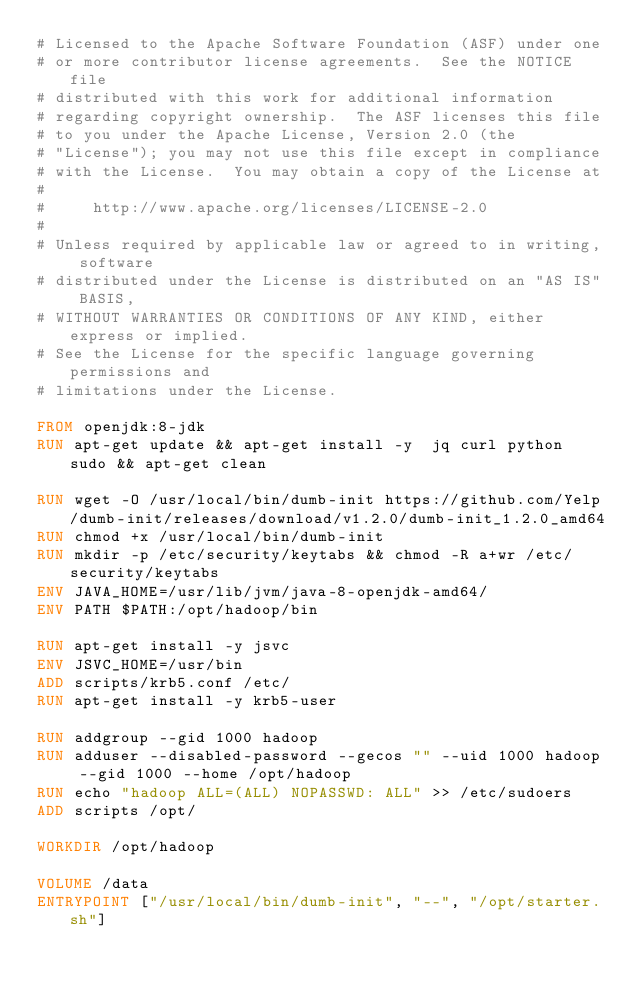Convert code to text. <code><loc_0><loc_0><loc_500><loc_500><_Dockerfile_># Licensed to the Apache Software Foundation (ASF) under one
# or more contributor license agreements.  See the NOTICE file
# distributed with this work for additional information
# regarding copyright ownership.  The ASF licenses this file
# to you under the Apache License, Version 2.0 (the
# "License"); you may not use this file except in compliance
# with the License.  You may obtain a copy of the License at
#
#     http://www.apache.org/licenses/LICENSE-2.0
#
# Unless required by applicable law or agreed to in writing, software
# distributed under the License is distributed on an "AS IS" BASIS,
# WITHOUT WARRANTIES OR CONDITIONS OF ANY KIND, either express or implied.
# See the License for the specific language governing permissions and
# limitations under the License.

FROM openjdk:8-jdk
RUN apt-get update && apt-get install -y  jq curl python sudo && apt-get clean

RUN wget -O /usr/local/bin/dumb-init https://github.com/Yelp/dumb-init/releases/download/v1.2.0/dumb-init_1.2.0_amd64
RUN chmod +x /usr/local/bin/dumb-init
RUN mkdir -p /etc/security/keytabs && chmod -R a+wr /etc/security/keytabs
ENV JAVA_HOME=/usr/lib/jvm/java-8-openjdk-amd64/
ENV PATH $PATH:/opt/hadoop/bin

RUN apt-get install -y jsvc
ENV JSVC_HOME=/usr/bin
ADD scripts/krb5.conf /etc/
RUN apt-get install -y krb5-user

RUN addgroup --gid 1000 hadoop
RUN adduser --disabled-password --gecos "" --uid 1000 hadoop --gid 1000 --home /opt/hadoop
RUN echo "hadoop ALL=(ALL) NOPASSWD: ALL" >> /etc/sudoers
ADD scripts /opt/

WORKDIR /opt/hadoop

VOLUME /data
ENTRYPOINT ["/usr/local/bin/dumb-init", "--", "/opt/starter.sh"]
</code> 